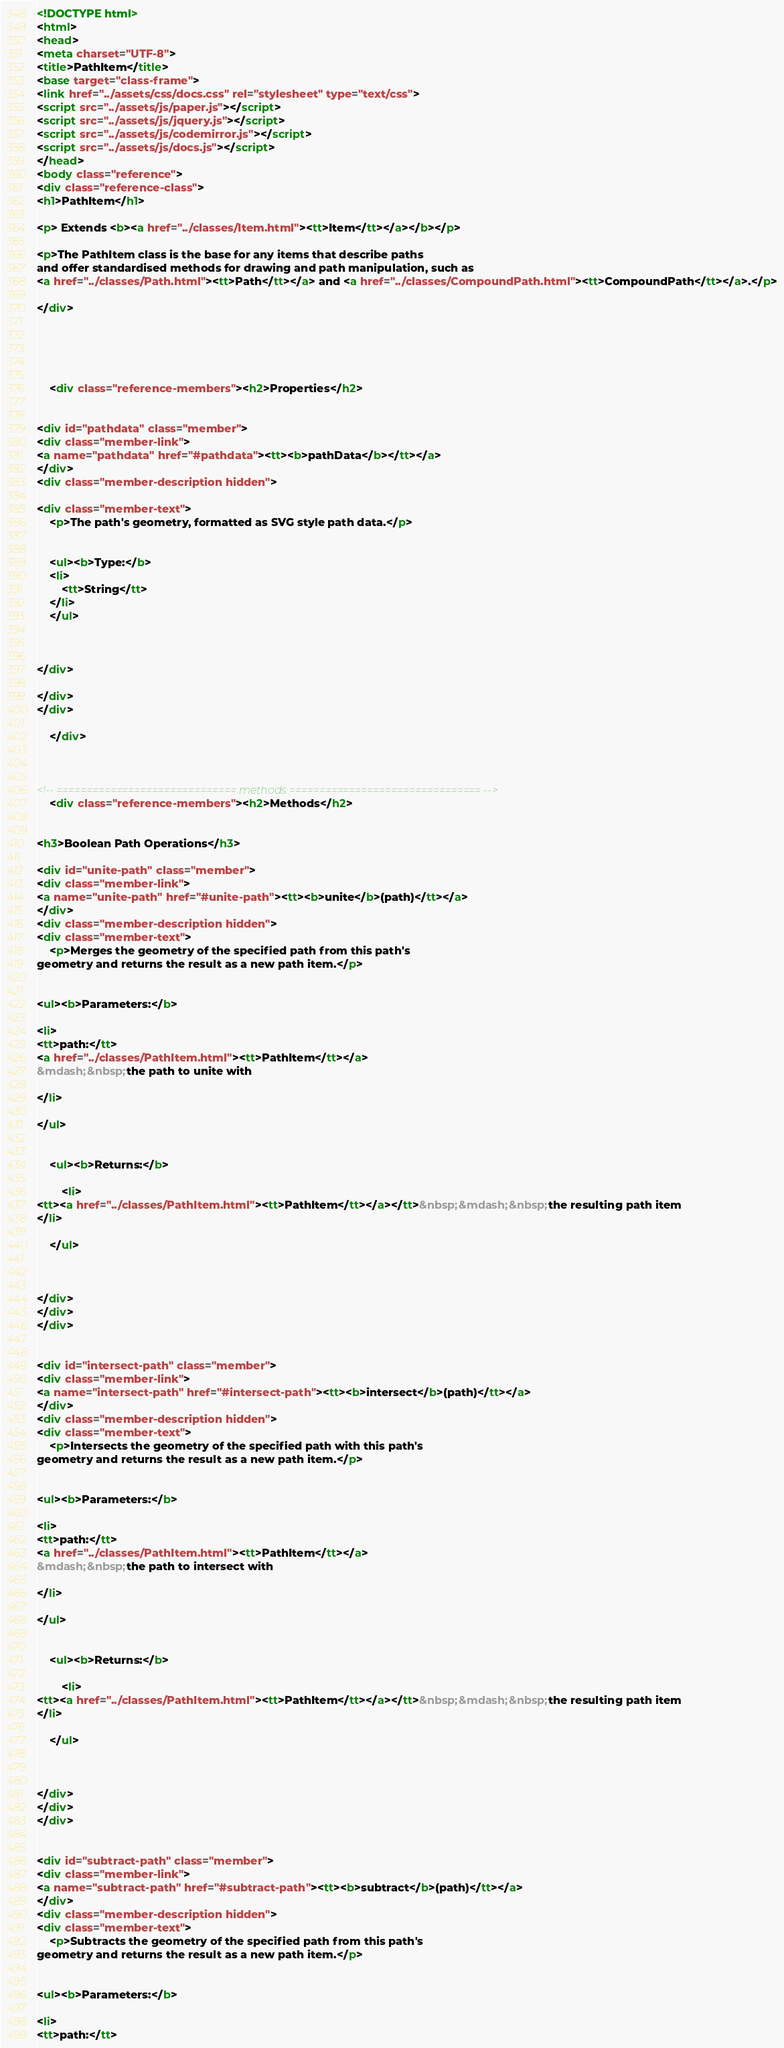<code> <loc_0><loc_0><loc_500><loc_500><_HTML_><!DOCTYPE html>
<html>
<head>
<meta charset="UTF-8">
<title>PathItem</title>
<base target="class-frame">
<link href="../assets/css/docs.css" rel="stylesheet" type="text/css">
<script src="../assets/js/paper.js"></script>
<script src="../assets/js/jquery.js"></script>
<script src="../assets/js/codemirror.js"></script>
<script src="../assets/js/docs.js"></script>
</head>
<body class="reference">
<div class="reference-class">
<h1>PathItem</h1>

<p> Extends <b><a href="../classes/Item.html"><tt>Item</tt></a></b></p>

<p>The PathItem class is the base for any items that describe paths
and offer standardised methods for drawing and path manipulation, such as
<a href="../classes/Path.html"><tt>Path</tt></a> and <a href="../classes/CompoundPath.html"><tt>CompoundPath</tt></a>.</p>

</div>





	<div class="reference-members"><h2>Properties</h2>
		
			
<div id="pathdata" class="member">
<div class="member-link">
<a name="pathdata" href="#pathdata"><tt><b>pathData</b></tt></a>
</div>
<div class="member-description hidden">

<div class="member-text">
	<p>The path's geometry, formatted as SVG style path data.</p>
	
	
	<ul><b>Type:</b>
	<li>
		<tt>String</tt>
	</li>
	</ul>
    
	
	
</div>

</div>
</div>
		
	</div>



<!-- ============================== methods ================================ -->
	<div class="reference-members"><h2>Methods</h2>
		
			
<h3>Boolean Path Operations</h3>

<div id="unite-path" class="member">
<div class="member-link">
<a name="unite-path" href="#unite-path"><tt><b>unite</b>(path)</tt></a>
</div>
<div class="member-description hidden">
<div class="member-text">
	<p>Merges the geometry of the specified path from this path's
geometry and returns the result as a new path item.</p>
    
	
<ul><b>Parameters:</b>

<li>
<tt>path:</tt> 
<a href="../classes/PathItem.html"><tt>PathItem</tt></a>
&mdash;&nbsp;the path to unite with

</li>

</ul>

	
	<ul><b>Returns:</b>
	
		<li>
<tt><a href="../classes/PathItem.html"><tt>PathItem</tt></a></tt>&nbsp;&mdash;&nbsp;the resulting path item
</li>
	
	</ul>

	
	
</div>
</div>
</div>
		
			
<div id="intersect-path" class="member">
<div class="member-link">
<a name="intersect-path" href="#intersect-path"><tt><b>intersect</b>(path)</tt></a>
</div>
<div class="member-description hidden">
<div class="member-text">
	<p>Intersects the geometry of the specified path with this path's
geometry and returns the result as a new path item.</p>
    
	
<ul><b>Parameters:</b>

<li>
<tt>path:</tt> 
<a href="../classes/PathItem.html"><tt>PathItem</tt></a>
&mdash;&nbsp;the path to intersect with

</li>

</ul>

	
	<ul><b>Returns:</b>
	
		<li>
<tt><a href="../classes/PathItem.html"><tt>PathItem</tt></a></tt>&nbsp;&mdash;&nbsp;the resulting path item
</li>
	
	</ul>

	
	
</div>
</div>
</div>
		
			
<div id="subtract-path" class="member">
<div class="member-link">
<a name="subtract-path" href="#subtract-path"><tt><b>subtract</b>(path)</tt></a>
</div>
<div class="member-description hidden">
<div class="member-text">
	<p>Subtracts the geometry of the specified path from this path's
geometry and returns the result as a new path item.</p>
    
	
<ul><b>Parameters:</b>

<li>
<tt>path:</tt> </code> 